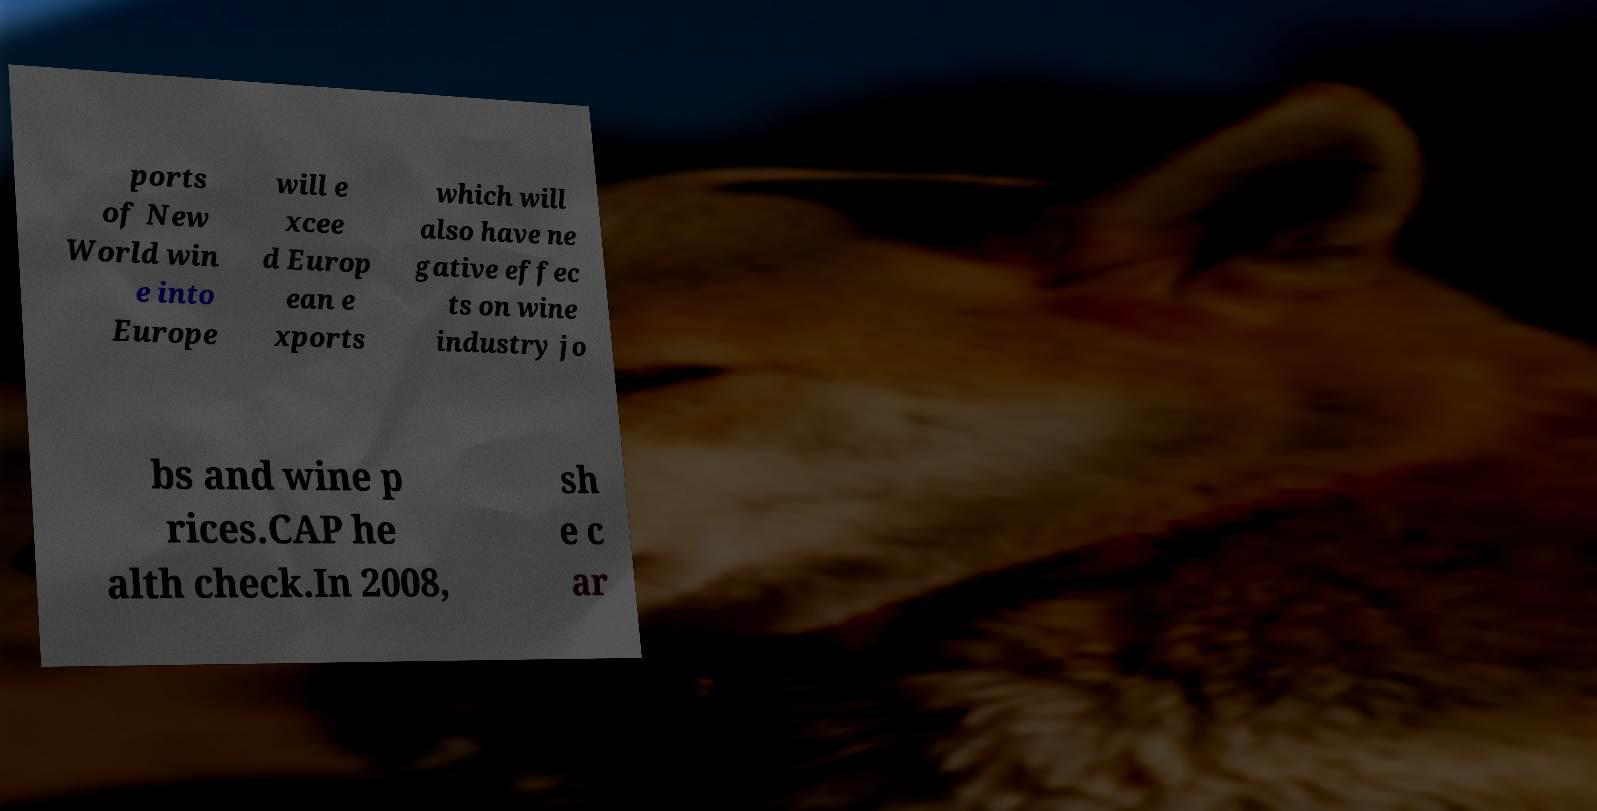Could you extract and type out the text from this image? ports of New World win e into Europe will e xcee d Europ ean e xports which will also have ne gative effec ts on wine industry jo bs and wine p rices.CAP he alth check.In 2008, sh e c ar 